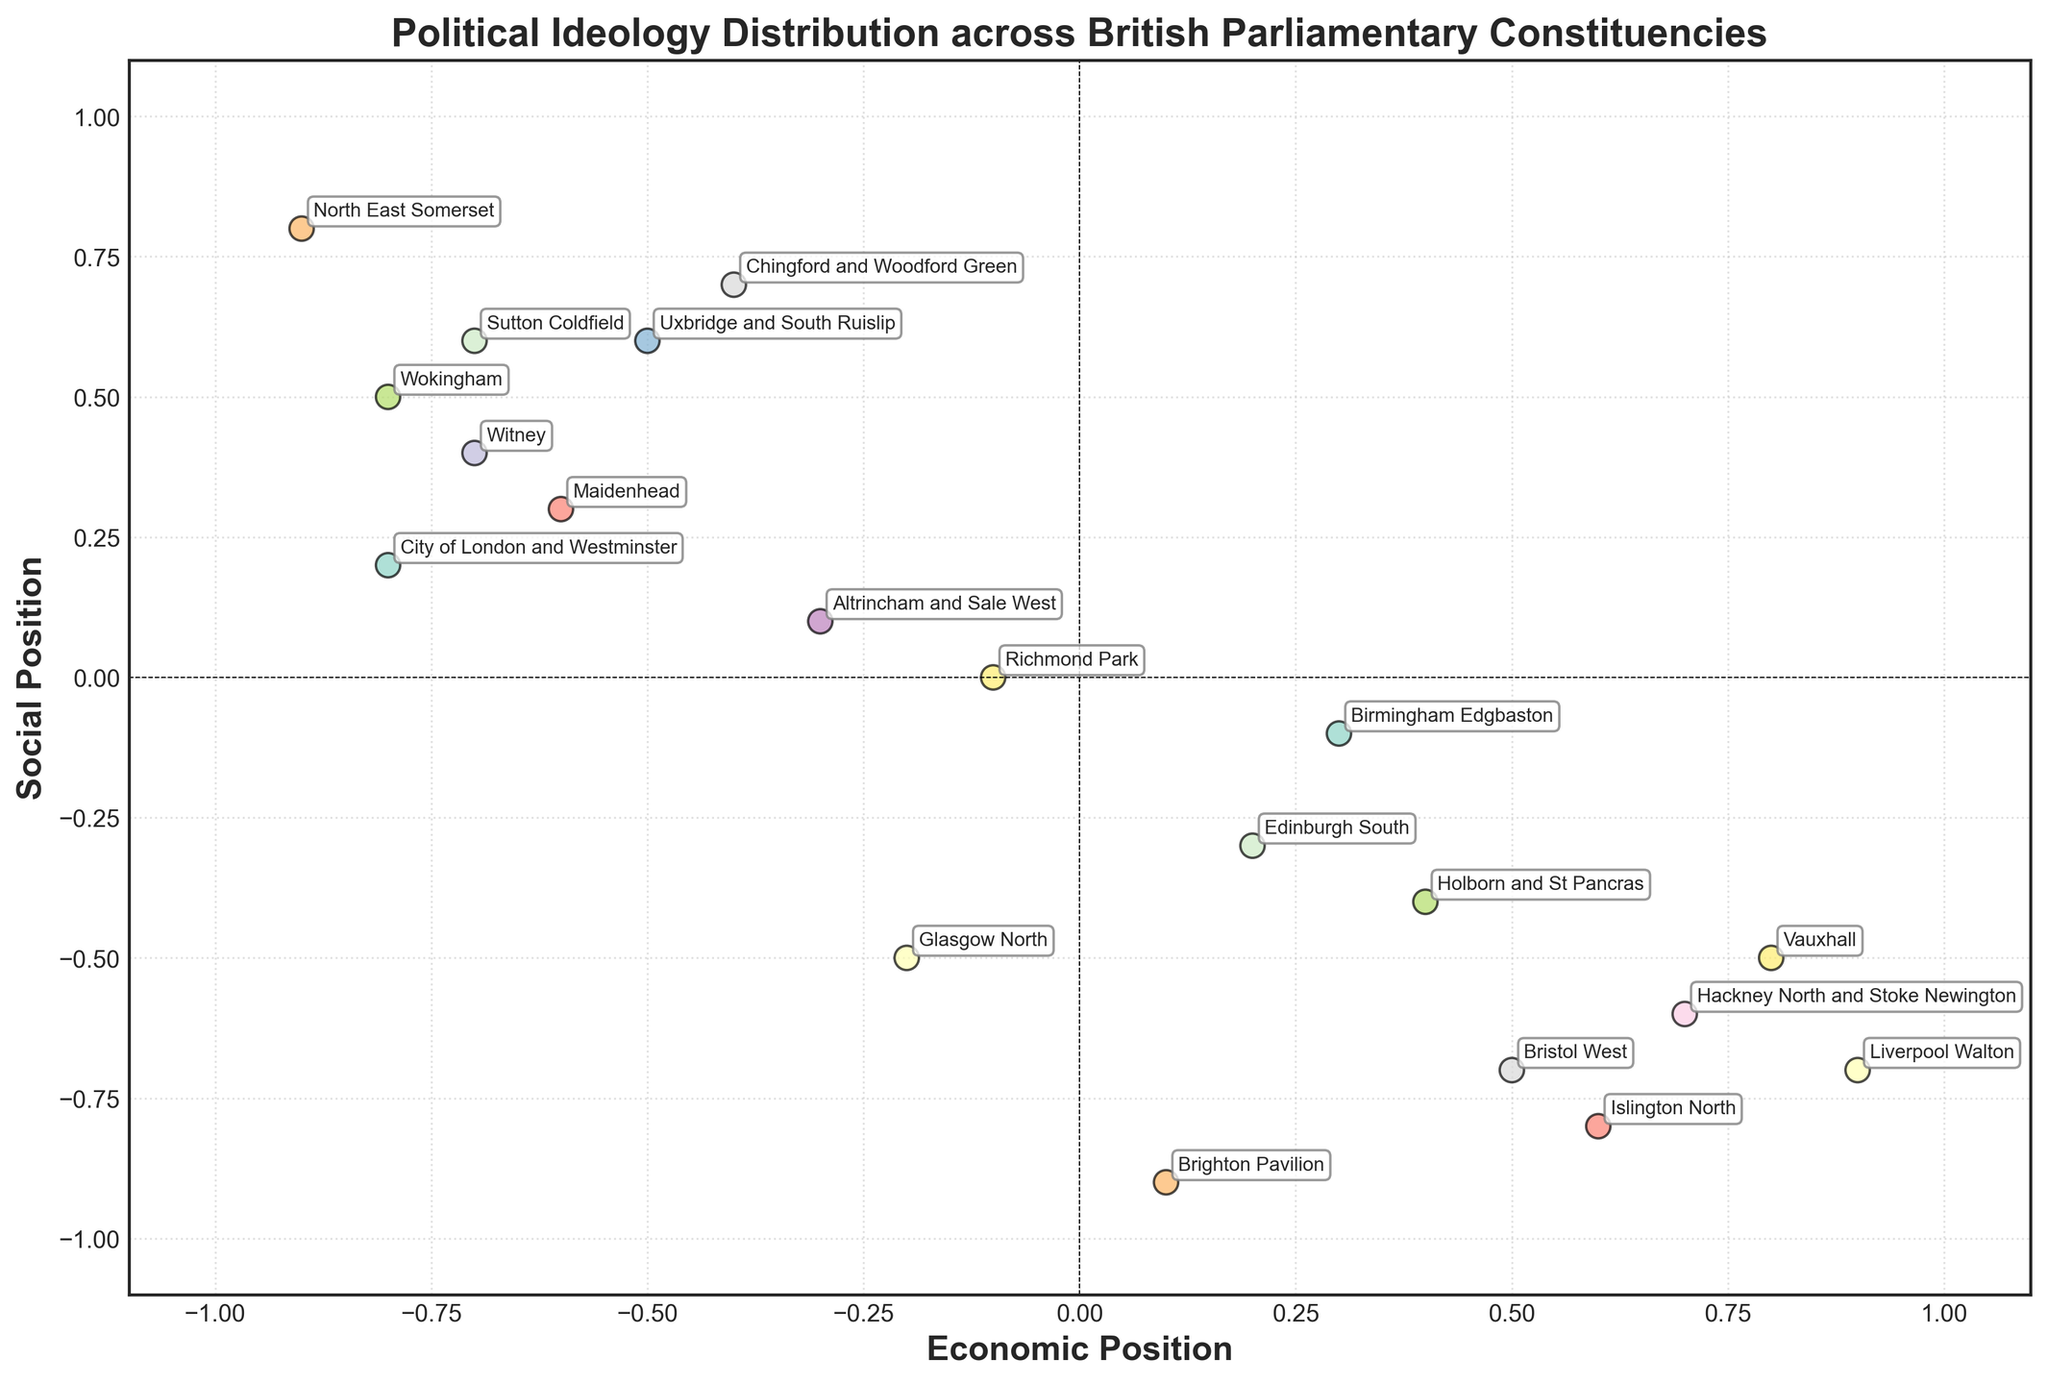What is the title of the plot? The title of the plot is displayed at the top of the figure. It reads "Political Ideology Distribution across British Parliamentary Constituencies".
Answer: Political Ideology Distribution across British Parliamentary Constituencies How many data points are shown in the plot? The number of data points corresponds to the number of constituencies listed in the data. By counting the unique annotations for each constituency, we see there are 19 data points.
Answer: 19 Which constituency has the highest Economic Position? The constituency with the highest Economic Position can be identified by finding the point furthest to the right on the X-axis. This is Liverpool Walton with an Economic Position of 0.9.
Answer: Liverpool Walton Which constituencies have positive values for both Economic Position and Social Position? Constituencies with positive values for both Economic Position and Social Position are located in the top-right quadrant of the plot. The annotations indicate these constituencies are Uxbridge and South Ruislip and North East Somerset.
Answer: Uxbridge and South Ruislip, North East Somerset Which constituency is situated closest to the origin? The point situated closest to the origin (0,0) can be identified by comparing the Euclidean distance from the origin for each point. Richmond Park is closest, with coordinates (-0.1, 0.0).
Answer: Richmond Park What is the average Economic Position of all constituencies? The average Economic Position is calculated by summing all Economic Positions and dividing by the number of constituencies. Sum of Economic Positions is -2.2 (sum of all values from the Economic_Position column) and there are 19 constituencies. -2.2 divided by 19 gives approximately -0.116.
Answer: -0.116 Which constituencies have a negative Social Position less than -0.5? Constituencies with a Social Position less than -0.5 are those below the bottom dashed line indicating y=0.0, and further below the -0.5 mark. These constituencies are Liverpool Walton, Islington North, Brighton Pavilion, Hackney North and Stoke Newington, Bristol West, and Vauxhall.
Answer: Liverpool Walton, Islington North, Brighton Pavilion, Hackney North and Stoke Newington, Bristol West, Vauxhall Which constituency has the highest Social Position? The constituency with the highest Social Position is the one with the largest value on the Y-axis. This is North East Somerset with a Social Position of 0.8.
Answer: North East Somerset How many constituencies fall in the top-left quadrant of the plot? The top-left quadrant consists of constituencies with negative Economic Positions and positive Social Positions. These can be counted as City of London and Westminster, Witney, Maidenhead, Wokingham, Chingford and Woodford Green, and Sutton Coldfield.
Answer: 6 Which constituencies appear at the extremes of the plot? The constituencies at the extremes of the plot are those farthest from the origin in any direction. Liverpool Walton (rightmost), Brighton Pavilion (bottom-most), and North East Somerset (top-most).
Answer: Liverpool Walton, Brighton Pavilion, North East Somerset 